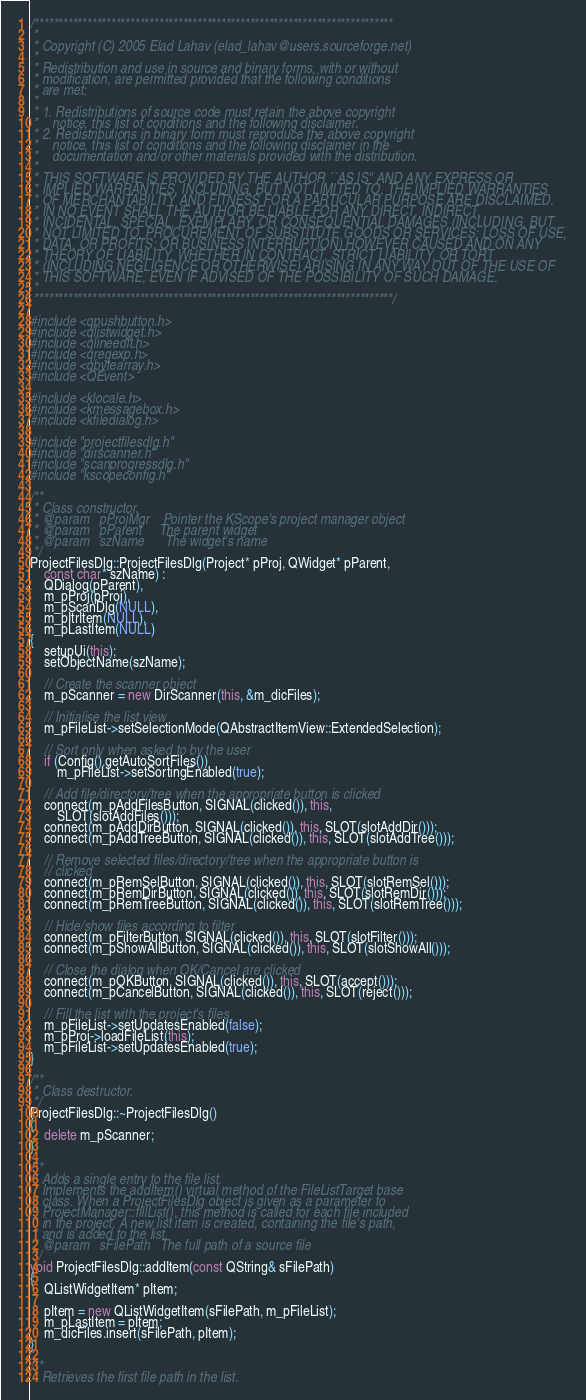<code> <loc_0><loc_0><loc_500><loc_500><_C++_>/***************************************************************************
 *
 * Copyright (C) 2005 Elad Lahav (elad_lahav@users.sourceforge.net)
 *
 * Redistribution and use in source and binary forms, with or without
 * modification, are permitted provided that the following conditions
 * are met:
 * 
 * 1. Redistributions of source code must retain the above copyright
 *    notice, this list of conditions and the following disclaimer.
 * 2. Redistributions in binary form must reproduce the above copyright
 *    notice, this list of conditions and the following disclaimer in the
 *    documentation and/or other materials provided with the distribution.
 * 
 * THIS SOFTWARE IS PROVIDED BY THE AUTHOR ``AS IS'' AND ANY EXPRESS OR
 * IMPLIED WARRANTIES, INCLUDING, BUT NOT LIMITED TO, THE IMPLIED WARRANTIES
 * OF MERCHANTABILITY AND FITNESS FOR A PARTICULAR PURPOSE ARE DISCLAIMED.
 * IN NO EVENT SHALL THE AUTHOR BE LIABLE FOR ANY DIRECT, INDIRECT,
 * INCIDENTAL, SPECIAL, EXEMPLARY, OR CONSEQUENTIAL DAMAGES (INCLUDING, BUT
 * NOT LIMITED TO, PROCUREMENT OF SUBSTITUTE GOODS OR SERVICES; LOSS OF USE,
 * DATA, OR PROFITS; OR BUSINESS INTERRUPTION) HOWEVER CAUSED AND ON ANY
 * THEORY OF LIABILITY, WHETHER IN CONTRACT, STRICT LIABILITY, OR TORT
 * (INCLUDING NEGLIGENCE OR OTHERWISE) ARISING IN ANY WAY OUT OF THE USE OF
 * THIS SOFTWARE, EVEN IF ADVISED OF THE POSSIBILITY OF SUCH DAMAGE.
 *
 ***************************************************************************/

#include <qpushbutton.h>
#include <qlistwidget.h>
#include <qlineedit.h>
#include <qregexp.h>
#include <qbytearray.h>
#include <QEvent>

#include <klocale.h>
#include <kmessagebox.h>
#include <kfiledialog.h>

#include "projectfilesdlg.h"
#include "dirscanner.h"
#include "scanprogressdlg.h"
#include "kscopeconfig.h"

/**
 * Class constructor.
 * @param	pProjMgr	Pointer the KScope's project manager object
 * @param	pParent		The parent widget
 * @param	szName		The widget's name
 */
ProjectFilesDlg::ProjectFilesDlg(Project* pProj, QWidget* pParent,
	const char* szName) :
	QDialog(pParent),
	m_pProj(pProj),
	m_pScanDlg(NULL),
	m_pItrItem(NULL),
	m_pLastItem(NULL)
{
	setupUi(this);
	setObjectName(szName);

	// Create the scanner object
	m_pScanner = new DirScanner(this, &m_dicFiles);

	// Initialise the list view
	m_pFileList->setSelectionMode(QAbstractItemView::ExtendedSelection);

	// Sort only when asked to by the user
	if (Config().getAutoSortFiles())
		m_pFileList->setSortingEnabled(true);

	// Add file/directory/tree when the appropriate button is clicked
	connect(m_pAddFilesButton, SIGNAL(clicked()), this,
		SLOT(slotAddFiles()));
	connect(m_pAddDirButton, SIGNAL(clicked()), this, SLOT(slotAddDir()));
	connect(m_pAddTreeButton, SIGNAL(clicked()), this, SLOT(slotAddTree()));

	// Remove selected files/directory/tree when the appropriate button is
	// clicked
	connect(m_pRemSelButton, SIGNAL(clicked()), this, SLOT(slotRemSel()));
	connect(m_pRemDirButton, SIGNAL(clicked()), this, SLOT(slotRemDir()));
	connect(m_pRemTreeButton, SIGNAL(clicked()), this, SLOT(slotRemTree()));

	// Hide/show files according to filter
	connect(m_pFilterButton, SIGNAL(clicked()), this, SLOT(slotFilter()));
	connect(m_pShowAllButton, SIGNAL(clicked()), this, SLOT(slotShowAll()));

	// Close the dialog when OK/Cancel are clicked
	connect(m_pOKButton, SIGNAL(clicked()), this, SLOT(accept()));
	connect(m_pCancelButton, SIGNAL(clicked()), this, SLOT(reject()));

	// Fill the list with the project's files
	m_pFileList->setUpdatesEnabled(false);
	m_pProj->loadFileList(this);
	m_pFileList->setUpdatesEnabled(true);
}

/**
 * Class destructor.
 */
ProjectFilesDlg::~ProjectFilesDlg()
{
	delete m_pScanner;
}

/**
 * Adds a single entry to the file list.
 * Implements the addItem() virtual method of the FileListTarget base
 * class. When a ProjectFilesDlg object is given as a parameter to
 * ProjectManager::fillList(), this method is called for each file included
 * in the project. A new list item is created, containing the file's path,
 * and is added to the list.
 * @param	sFilePath	The full path of a source file
 */
void ProjectFilesDlg::addItem(const QString& sFilePath)
{
	QListWidgetItem* pItem;

	pItem = new QListWidgetItem(sFilePath, m_pFileList);
	m_pLastItem = pItem;
	m_dicFiles.insert(sFilePath, pItem);
}

/**
 * Retrieves the first file path in the list.</code> 